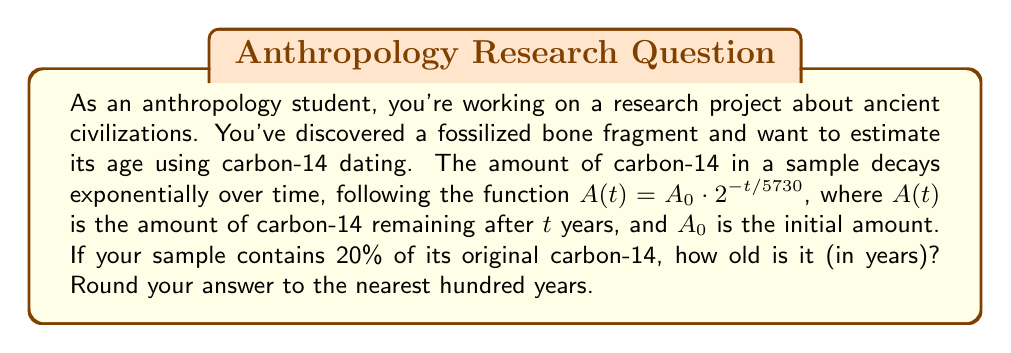Solve this math problem. Let's approach this step-by-step:

1) We're given the decay function: $A(t) = A_0 \cdot 2^{-t/5730}$

2) We know that 20% of the original carbon-14 remains. This means:
   $\frac{A(t)}{A_0} = 0.20$

3) We can set up the equation:
   $0.20 = 2^{-t/5730}$

4) To solve for $t$, we need to use logarithms. Let's apply $\log_2$ to both sides:
   $\log_2(0.20) = \log_2(2^{-t/5730})$

5) Using the logarithm property $\log_a(x^n) = n\log_a(x)$:
   $\log_2(0.20) = -\frac{t}{5730} \cdot \log_2(2)$

6) Since $\log_2(2) = 1$, we have:
   $\log_2(0.20) = -\frac{t}{5730}$

7) Solving for $t$:
   $t = -5730 \cdot \log_2(0.20)$

8) Calculate:
   $t = -5730 \cdot (-2.3219280948873623...)$
   $t = 13304.57798350519...$

9) Rounding to the nearest hundred years:
   $t \approx 13300$ years
Answer: The fossilized bone fragment is approximately 13,300 years old. 